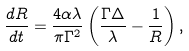Convert formula to latex. <formula><loc_0><loc_0><loc_500><loc_500>\frac { d R } { d t } = \frac { 4 \alpha \lambda } { \pi \Gamma ^ { 2 } } \left ( \frac { \Gamma \Delta } { \lambda } - \frac { 1 } { R } \right ) ,</formula> 